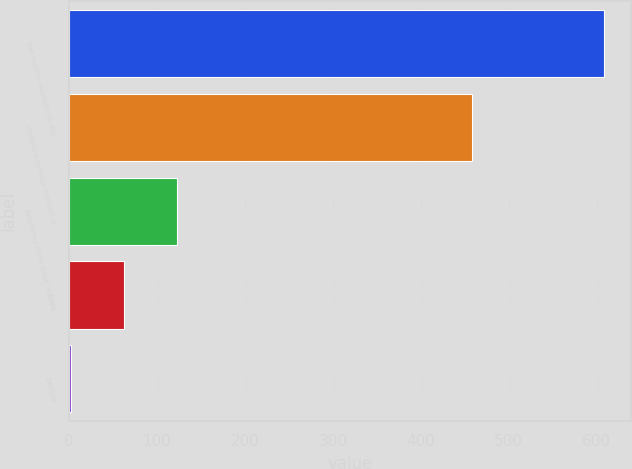<chart> <loc_0><loc_0><loc_500><loc_500><bar_chart><fcel>Net income available to IPG<fcel>Weighted-average number of<fcel>Restricted stock stock options<fcel>Basic<fcel>Diluted<nl><fcel>608.5<fcel>458.6<fcel>122.89<fcel>62.19<fcel>1.49<nl></chart> 